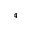<formula> <loc_0><loc_0><loc_500><loc_500>_ { 4 }</formula> 